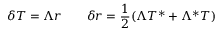Convert formula to latex. <formula><loc_0><loc_0><loc_500><loc_500>\delta T = \Lambda r \quad \delta r = { \frac { 1 } { 2 } } ( \Lambda T ^ { * } + \Lambda ^ { * } T )</formula> 